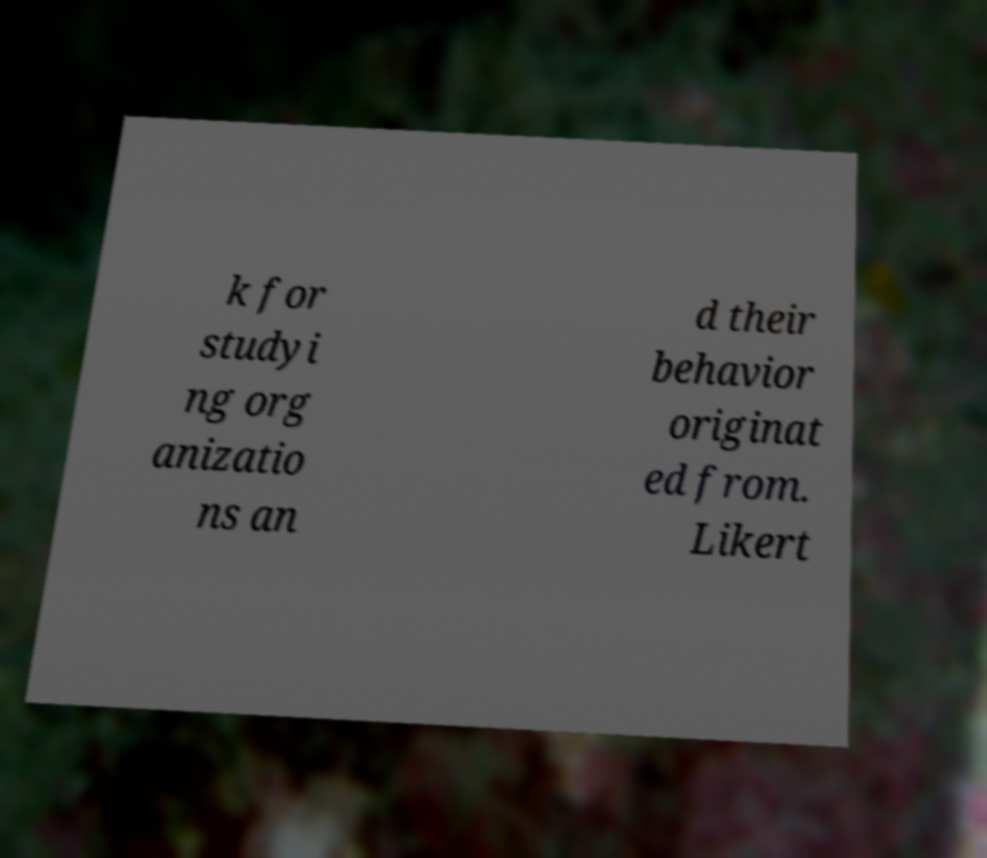Could you assist in decoding the text presented in this image and type it out clearly? k for studyi ng org anizatio ns an d their behavior originat ed from. Likert 